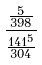Convert formula to latex. <formula><loc_0><loc_0><loc_500><loc_500>\frac { \frac { 5 } { 3 9 8 } } { \frac { 1 4 1 ^ { 5 } } { 3 0 4 } }</formula> 